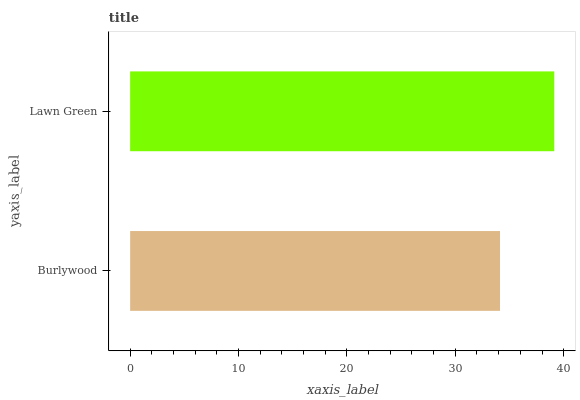Is Burlywood the minimum?
Answer yes or no. Yes. Is Lawn Green the maximum?
Answer yes or no. Yes. Is Lawn Green the minimum?
Answer yes or no. No. Is Lawn Green greater than Burlywood?
Answer yes or no. Yes. Is Burlywood less than Lawn Green?
Answer yes or no. Yes. Is Burlywood greater than Lawn Green?
Answer yes or no. No. Is Lawn Green less than Burlywood?
Answer yes or no. No. Is Lawn Green the high median?
Answer yes or no. Yes. Is Burlywood the low median?
Answer yes or no. Yes. Is Burlywood the high median?
Answer yes or no. No. Is Lawn Green the low median?
Answer yes or no. No. 